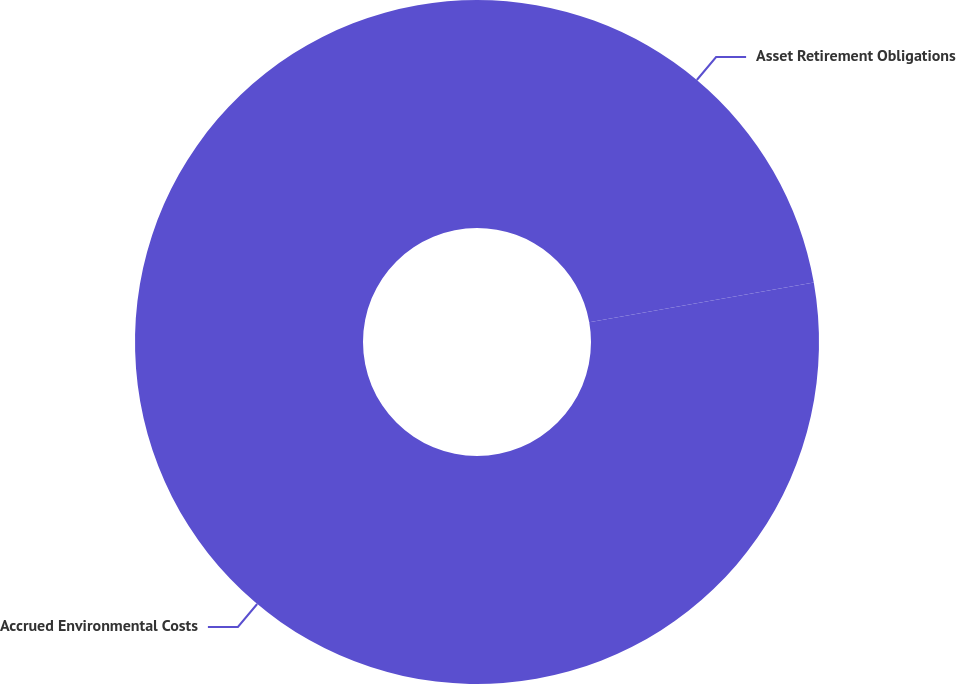Convert chart to OTSL. <chart><loc_0><loc_0><loc_500><loc_500><pie_chart><fcel>Asset Retirement Obligations<fcel>Accrued Environmental Costs<nl><fcel>22.22%<fcel>77.78%<nl></chart> 